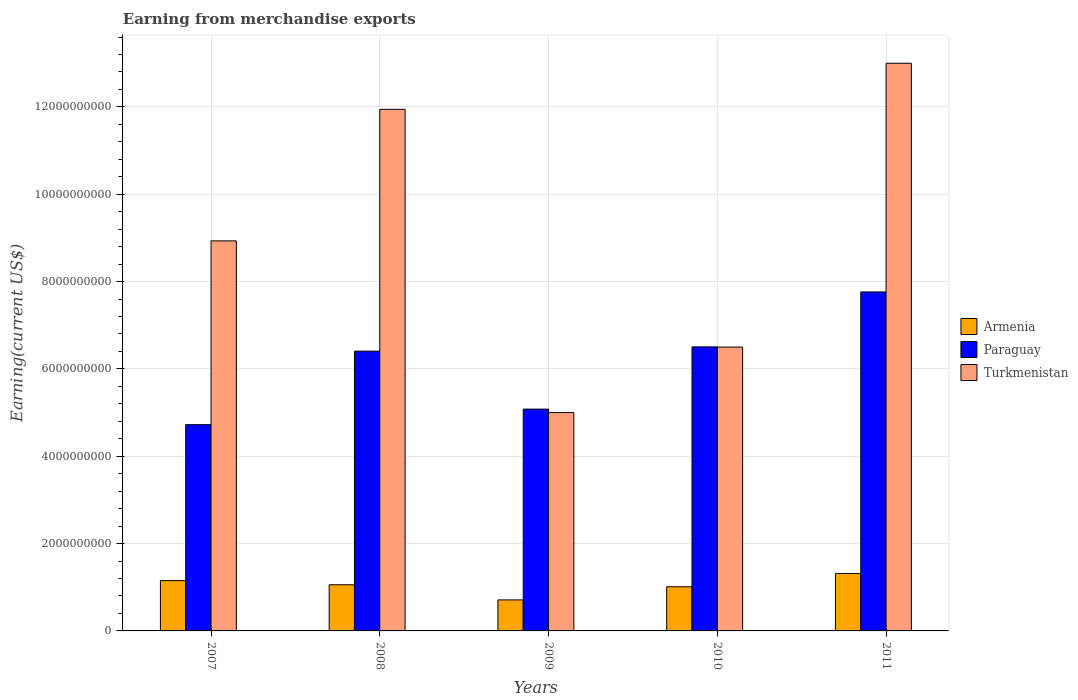How many groups of bars are there?
Your answer should be very brief. 5. Are the number of bars on each tick of the X-axis equal?
Your answer should be very brief. Yes. How many bars are there on the 2nd tick from the left?
Your answer should be very brief. 3. In how many cases, is the number of bars for a given year not equal to the number of legend labels?
Provide a short and direct response. 0. What is the amount earned from merchandise exports in Armenia in 2011?
Offer a terse response. 1.32e+09. Across all years, what is the maximum amount earned from merchandise exports in Turkmenistan?
Make the answer very short. 1.30e+1. Across all years, what is the minimum amount earned from merchandise exports in Paraguay?
Keep it short and to the point. 4.72e+09. In which year was the amount earned from merchandise exports in Paraguay maximum?
Ensure brevity in your answer.  2011. In which year was the amount earned from merchandise exports in Turkmenistan minimum?
Keep it short and to the point. 2009. What is the total amount earned from merchandise exports in Armenia in the graph?
Provide a short and direct response. 5.25e+09. What is the difference between the amount earned from merchandise exports in Turkmenistan in 2008 and that in 2011?
Make the answer very short. -1.06e+09. What is the difference between the amount earned from merchandise exports in Turkmenistan in 2010 and the amount earned from merchandise exports in Paraguay in 2009?
Ensure brevity in your answer.  1.42e+09. What is the average amount earned from merchandise exports in Turkmenistan per year?
Ensure brevity in your answer.  9.08e+09. In the year 2011, what is the difference between the amount earned from merchandise exports in Paraguay and amount earned from merchandise exports in Turkmenistan?
Offer a very short reply. -5.24e+09. In how many years, is the amount earned from merchandise exports in Armenia greater than 800000000 US$?
Make the answer very short. 4. What is the ratio of the amount earned from merchandise exports in Turkmenistan in 2007 to that in 2010?
Ensure brevity in your answer.  1.37. Is the amount earned from merchandise exports in Paraguay in 2007 less than that in 2009?
Your answer should be compact. Yes. What is the difference between the highest and the second highest amount earned from merchandise exports in Armenia?
Ensure brevity in your answer.  1.63e+08. What is the difference between the highest and the lowest amount earned from merchandise exports in Turkmenistan?
Offer a terse response. 8.00e+09. Is the sum of the amount earned from merchandise exports in Turkmenistan in 2008 and 2010 greater than the maximum amount earned from merchandise exports in Paraguay across all years?
Make the answer very short. Yes. What does the 3rd bar from the left in 2008 represents?
Provide a short and direct response. Turkmenistan. What does the 3rd bar from the right in 2010 represents?
Make the answer very short. Armenia. Are all the bars in the graph horizontal?
Offer a terse response. No. How many years are there in the graph?
Offer a terse response. 5. Does the graph contain any zero values?
Provide a succinct answer. No. Does the graph contain grids?
Keep it short and to the point. Yes. Where does the legend appear in the graph?
Your response must be concise. Center right. How many legend labels are there?
Your response must be concise. 3. How are the legend labels stacked?
Make the answer very short. Vertical. What is the title of the graph?
Provide a short and direct response. Earning from merchandise exports. What is the label or title of the Y-axis?
Your response must be concise. Earning(current US$). What is the Earning(current US$) of Armenia in 2007?
Ensure brevity in your answer.  1.15e+09. What is the Earning(current US$) of Paraguay in 2007?
Your response must be concise. 4.72e+09. What is the Earning(current US$) of Turkmenistan in 2007?
Give a very brief answer. 8.93e+09. What is the Earning(current US$) in Armenia in 2008?
Provide a short and direct response. 1.06e+09. What is the Earning(current US$) in Paraguay in 2008?
Your answer should be compact. 6.41e+09. What is the Earning(current US$) of Turkmenistan in 2008?
Your answer should be compact. 1.19e+1. What is the Earning(current US$) of Armenia in 2009?
Offer a very short reply. 7.10e+08. What is the Earning(current US$) in Paraguay in 2009?
Ensure brevity in your answer.  5.08e+09. What is the Earning(current US$) in Turkmenistan in 2009?
Your answer should be compact. 5.00e+09. What is the Earning(current US$) in Armenia in 2010?
Make the answer very short. 1.01e+09. What is the Earning(current US$) in Paraguay in 2010?
Keep it short and to the point. 6.50e+09. What is the Earning(current US$) in Turkmenistan in 2010?
Offer a very short reply. 6.50e+09. What is the Earning(current US$) of Armenia in 2011?
Give a very brief answer. 1.32e+09. What is the Earning(current US$) in Paraguay in 2011?
Provide a short and direct response. 7.76e+09. What is the Earning(current US$) in Turkmenistan in 2011?
Your answer should be very brief. 1.30e+1. Across all years, what is the maximum Earning(current US$) in Armenia?
Keep it short and to the point. 1.32e+09. Across all years, what is the maximum Earning(current US$) of Paraguay?
Keep it short and to the point. 7.76e+09. Across all years, what is the maximum Earning(current US$) of Turkmenistan?
Ensure brevity in your answer.  1.30e+1. Across all years, what is the minimum Earning(current US$) of Armenia?
Your answer should be very brief. 7.10e+08. Across all years, what is the minimum Earning(current US$) of Paraguay?
Give a very brief answer. 4.72e+09. Across all years, what is the minimum Earning(current US$) in Turkmenistan?
Your response must be concise. 5.00e+09. What is the total Earning(current US$) of Armenia in the graph?
Your response must be concise. 5.25e+09. What is the total Earning(current US$) in Paraguay in the graph?
Provide a short and direct response. 3.05e+1. What is the total Earning(current US$) in Turkmenistan in the graph?
Provide a short and direct response. 4.54e+1. What is the difference between the Earning(current US$) in Armenia in 2007 and that in 2008?
Your response must be concise. 9.51e+07. What is the difference between the Earning(current US$) of Paraguay in 2007 and that in 2008?
Give a very brief answer. -1.68e+09. What is the difference between the Earning(current US$) of Turkmenistan in 2007 and that in 2008?
Your response must be concise. -3.01e+09. What is the difference between the Earning(current US$) in Armenia in 2007 and that in 2009?
Offer a very short reply. 4.42e+08. What is the difference between the Earning(current US$) of Paraguay in 2007 and that in 2009?
Make the answer very short. -3.56e+08. What is the difference between the Earning(current US$) in Turkmenistan in 2007 and that in 2009?
Provide a short and direct response. 3.93e+09. What is the difference between the Earning(current US$) in Armenia in 2007 and that in 2010?
Keep it short and to the point. 1.41e+08. What is the difference between the Earning(current US$) in Paraguay in 2007 and that in 2010?
Provide a succinct answer. -1.78e+09. What is the difference between the Earning(current US$) in Turkmenistan in 2007 and that in 2010?
Offer a terse response. 2.43e+09. What is the difference between the Earning(current US$) of Armenia in 2007 and that in 2011?
Keep it short and to the point. -1.63e+08. What is the difference between the Earning(current US$) in Paraguay in 2007 and that in 2011?
Offer a terse response. -3.04e+09. What is the difference between the Earning(current US$) of Turkmenistan in 2007 and that in 2011?
Provide a short and direct response. -4.07e+09. What is the difference between the Earning(current US$) in Armenia in 2008 and that in 2009?
Offer a very short reply. 3.47e+08. What is the difference between the Earning(current US$) of Paraguay in 2008 and that in 2009?
Offer a very short reply. 1.33e+09. What is the difference between the Earning(current US$) of Turkmenistan in 2008 and that in 2009?
Make the answer very short. 6.94e+09. What is the difference between the Earning(current US$) of Armenia in 2008 and that in 2010?
Offer a very short reply. 4.58e+07. What is the difference between the Earning(current US$) in Paraguay in 2008 and that in 2010?
Provide a succinct answer. -9.77e+07. What is the difference between the Earning(current US$) of Turkmenistan in 2008 and that in 2010?
Keep it short and to the point. 5.44e+09. What is the difference between the Earning(current US$) of Armenia in 2008 and that in 2011?
Make the answer very short. -2.58e+08. What is the difference between the Earning(current US$) in Paraguay in 2008 and that in 2011?
Ensure brevity in your answer.  -1.36e+09. What is the difference between the Earning(current US$) in Turkmenistan in 2008 and that in 2011?
Your response must be concise. -1.06e+09. What is the difference between the Earning(current US$) of Armenia in 2009 and that in 2010?
Make the answer very short. -3.01e+08. What is the difference between the Earning(current US$) in Paraguay in 2009 and that in 2010?
Offer a very short reply. -1.43e+09. What is the difference between the Earning(current US$) in Turkmenistan in 2009 and that in 2010?
Make the answer very short. -1.50e+09. What is the difference between the Earning(current US$) of Armenia in 2009 and that in 2011?
Make the answer very short. -6.05e+08. What is the difference between the Earning(current US$) of Paraguay in 2009 and that in 2011?
Offer a terse response. -2.68e+09. What is the difference between the Earning(current US$) in Turkmenistan in 2009 and that in 2011?
Your response must be concise. -8.00e+09. What is the difference between the Earning(current US$) of Armenia in 2010 and that in 2011?
Your answer should be very brief. -3.04e+08. What is the difference between the Earning(current US$) in Paraguay in 2010 and that in 2011?
Your answer should be compact. -1.26e+09. What is the difference between the Earning(current US$) of Turkmenistan in 2010 and that in 2011?
Make the answer very short. -6.50e+09. What is the difference between the Earning(current US$) in Armenia in 2007 and the Earning(current US$) in Paraguay in 2008?
Ensure brevity in your answer.  -5.25e+09. What is the difference between the Earning(current US$) in Armenia in 2007 and the Earning(current US$) in Turkmenistan in 2008?
Your answer should be very brief. -1.08e+1. What is the difference between the Earning(current US$) in Paraguay in 2007 and the Earning(current US$) in Turkmenistan in 2008?
Give a very brief answer. -7.22e+09. What is the difference between the Earning(current US$) of Armenia in 2007 and the Earning(current US$) of Paraguay in 2009?
Offer a very short reply. -3.93e+09. What is the difference between the Earning(current US$) of Armenia in 2007 and the Earning(current US$) of Turkmenistan in 2009?
Offer a terse response. -3.85e+09. What is the difference between the Earning(current US$) of Paraguay in 2007 and the Earning(current US$) of Turkmenistan in 2009?
Keep it short and to the point. -2.76e+08. What is the difference between the Earning(current US$) in Armenia in 2007 and the Earning(current US$) in Paraguay in 2010?
Your answer should be compact. -5.35e+09. What is the difference between the Earning(current US$) of Armenia in 2007 and the Earning(current US$) of Turkmenistan in 2010?
Offer a terse response. -5.35e+09. What is the difference between the Earning(current US$) of Paraguay in 2007 and the Earning(current US$) of Turkmenistan in 2010?
Your answer should be very brief. -1.78e+09. What is the difference between the Earning(current US$) of Armenia in 2007 and the Earning(current US$) of Paraguay in 2011?
Your answer should be very brief. -6.61e+09. What is the difference between the Earning(current US$) of Armenia in 2007 and the Earning(current US$) of Turkmenistan in 2011?
Provide a short and direct response. -1.18e+1. What is the difference between the Earning(current US$) in Paraguay in 2007 and the Earning(current US$) in Turkmenistan in 2011?
Provide a short and direct response. -8.28e+09. What is the difference between the Earning(current US$) of Armenia in 2008 and the Earning(current US$) of Paraguay in 2009?
Provide a short and direct response. -4.02e+09. What is the difference between the Earning(current US$) of Armenia in 2008 and the Earning(current US$) of Turkmenistan in 2009?
Ensure brevity in your answer.  -3.94e+09. What is the difference between the Earning(current US$) of Paraguay in 2008 and the Earning(current US$) of Turkmenistan in 2009?
Offer a very short reply. 1.41e+09. What is the difference between the Earning(current US$) in Armenia in 2008 and the Earning(current US$) in Paraguay in 2010?
Make the answer very short. -5.45e+09. What is the difference between the Earning(current US$) in Armenia in 2008 and the Earning(current US$) in Turkmenistan in 2010?
Make the answer very short. -5.44e+09. What is the difference between the Earning(current US$) in Paraguay in 2008 and the Earning(current US$) in Turkmenistan in 2010?
Provide a short and direct response. -9.29e+07. What is the difference between the Earning(current US$) of Armenia in 2008 and the Earning(current US$) of Paraguay in 2011?
Offer a very short reply. -6.71e+09. What is the difference between the Earning(current US$) in Armenia in 2008 and the Earning(current US$) in Turkmenistan in 2011?
Your response must be concise. -1.19e+1. What is the difference between the Earning(current US$) of Paraguay in 2008 and the Earning(current US$) of Turkmenistan in 2011?
Offer a terse response. -6.59e+09. What is the difference between the Earning(current US$) in Armenia in 2009 and the Earning(current US$) in Paraguay in 2010?
Make the answer very short. -5.79e+09. What is the difference between the Earning(current US$) of Armenia in 2009 and the Earning(current US$) of Turkmenistan in 2010?
Give a very brief answer. -5.79e+09. What is the difference between the Earning(current US$) of Paraguay in 2009 and the Earning(current US$) of Turkmenistan in 2010?
Make the answer very short. -1.42e+09. What is the difference between the Earning(current US$) of Armenia in 2009 and the Earning(current US$) of Paraguay in 2011?
Your response must be concise. -7.05e+09. What is the difference between the Earning(current US$) of Armenia in 2009 and the Earning(current US$) of Turkmenistan in 2011?
Offer a very short reply. -1.23e+1. What is the difference between the Earning(current US$) in Paraguay in 2009 and the Earning(current US$) in Turkmenistan in 2011?
Your response must be concise. -7.92e+09. What is the difference between the Earning(current US$) in Armenia in 2010 and the Earning(current US$) in Paraguay in 2011?
Provide a succinct answer. -6.75e+09. What is the difference between the Earning(current US$) of Armenia in 2010 and the Earning(current US$) of Turkmenistan in 2011?
Your answer should be very brief. -1.20e+1. What is the difference between the Earning(current US$) in Paraguay in 2010 and the Earning(current US$) in Turkmenistan in 2011?
Make the answer very short. -6.50e+09. What is the average Earning(current US$) in Armenia per year?
Your answer should be compact. 1.05e+09. What is the average Earning(current US$) in Paraguay per year?
Your answer should be very brief. 6.10e+09. What is the average Earning(current US$) in Turkmenistan per year?
Offer a very short reply. 9.08e+09. In the year 2007, what is the difference between the Earning(current US$) of Armenia and Earning(current US$) of Paraguay?
Give a very brief answer. -3.57e+09. In the year 2007, what is the difference between the Earning(current US$) of Armenia and Earning(current US$) of Turkmenistan?
Keep it short and to the point. -7.78e+09. In the year 2007, what is the difference between the Earning(current US$) of Paraguay and Earning(current US$) of Turkmenistan?
Your response must be concise. -4.21e+09. In the year 2008, what is the difference between the Earning(current US$) in Armenia and Earning(current US$) in Paraguay?
Offer a terse response. -5.35e+09. In the year 2008, what is the difference between the Earning(current US$) of Armenia and Earning(current US$) of Turkmenistan?
Provide a short and direct response. -1.09e+1. In the year 2008, what is the difference between the Earning(current US$) in Paraguay and Earning(current US$) in Turkmenistan?
Your response must be concise. -5.54e+09. In the year 2009, what is the difference between the Earning(current US$) of Armenia and Earning(current US$) of Paraguay?
Provide a short and direct response. -4.37e+09. In the year 2009, what is the difference between the Earning(current US$) in Armenia and Earning(current US$) in Turkmenistan?
Your response must be concise. -4.29e+09. In the year 2009, what is the difference between the Earning(current US$) of Paraguay and Earning(current US$) of Turkmenistan?
Make the answer very short. 7.96e+07. In the year 2010, what is the difference between the Earning(current US$) in Armenia and Earning(current US$) in Paraguay?
Your answer should be very brief. -5.49e+09. In the year 2010, what is the difference between the Earning(current US$) of Armenia and Earning(current US$) of Turkmenistan?
Offer a very short reply. -5.49e+09. In the year 2010, what is the difference between the Earning(current US$) of Paraguay and Earning(current US$) of Turkmenistan?
Offer a very short reply. 4.82e+06. In the year 2011, what is the difference between the Earning(current US$) of Armenia and Earning(current US$) of Paraguay?
Your response must be concise. -6.45e+09. In the year 2011, what is the difference between the Earning(current US$) in Armenia and Earning(current US$) in Turkmenistan?
Ensure brevity in your answer.  -1.17e+1. In the year 2011, what is the difference between the Earning(current US$) in Paraguay and Earning(current US$) in Turkmenistan?
Your answer should be compact. -5.24e+09. What is the ratio of the Earning(current US$) of Armenia in 2007 to that in 2008?
Keep it short and to the point. 1.09. What is the ratio of the Earning(current US$) in Paraguay in 2007 to that in 2008?
Your answer should be compact. 0.74. What is the ratio of the Earning(current US$) in Turkmenistan in 2007 to that in 2008?
Provide a succinct answer. 0.75. What is the ratio of the Earning(current US$) in Armenia in 2007 to that in 2009?
Provide a succinct answer. 1.62. What is the ratio of the Earning(current US$) of Paraguay in 2007 to that in 2009?
Your response must be concise. 0.93. What is the ratio of the Earning(current US$) in Turkmenistan in 2007 to that in 2009?
Offer a terse response. 1.79. What is the ratio of the Earning(current US$) of Armenia in 2007 to that in 2010?
Offer a very short reply. 1.14. What is the ratio of the Earning(current US$) in Paraguay in 2007 to that in 2010?
Offer a very short reply. 0.73. What is the ratio of the Earning(current US$) in Turkmenistan in 2007 to that in 2010?
Your answer should be very brief. 1.37. What is the ratio of the Earning(current US$) in Armenia in 2007 to that in 2011?
Keep it short and to the point. 0.88. What is the ratio of the Earning(current US$) in Paraguay in 2007 to that in 2011?
Make the answer very short. 0.61. What is the ratio of the Earning(current US$) of Turkmenistan in 2007 to that in 2011?
Offer a terse response. 0.69. What is the ratio of the Earning(current US$) in Armenia in 2008 to that in 2009?
Your response must be concise. 1.49. What is the ratio of the Earning(current US$) in Paraguay in 2008 to that in 2009?
Provide a succinct answer. 1.26. What is the ratio of the Earning(current US$) in Turkmenistan in 2008 to that in 2009?
Provide a short and direct response. 2.39. What is the ratio of the Earning(current US$) of Armenia in 2008 to that in 2010?
Keep it short and to the point. 1.05. What is the ratio of the Earning(current US$) of Paraguay in 2008 to that in 2010?
Provide a succinct answer. 0.98. What is the ratio of the Earning(current US$) of Turkmenistan in 2008 to that in 2010?
Offer a very short reply. 1.84. What is the ratio of the Earning(current US$) in Armenia in 2008 to that in 2011?
Provide a succinct answer. 0.8. What is the ratio of the Earning(current US$) in Paraguay in 2008 to that in 2011?
Ensure brevity in your answer.  0.83. What is the ratio of the Earning(current US$) of Turkmenistan in 2008 to that in 2011?
Provide a short and direct response. 0.92. What is the ratio of the Earning(current US$) in Armenia in 2009 to that in 2010?
Your response must be concise. 0.7. What is the ratio of the Earning(current US$) of Paraguay in 2009 to that in 2010?
Your answer should be compact. 0.78. What is the ratio of the Earning(current US$) in Turkmenistan in 2009 to that in 2010?
Offer a very short reply. 0.77. What is the ratio of the Earning(current US$) in Armenia in 2009 to that in 2011?
Keep it short and to the point. 0.54. What is the ratio of the Earning(current US$) in Paraguay in 2009 to that in 2011?
Your answer should be very brief. 0.65. What is the ratio of the Earning(current US$) in Turkmenistan in 2009 to that in 2011?
Ensure brevity in your answer.  0.38. What is the ratio of the Earning(current US$) of Armenia in 2010 to that in 2011?
Your answer should be very brief. 0.77. What is the ratio of the Earning(current US$) of Paraguay in 2010 to that in 2011?
Your response must be concise. 0.84. What is the ratio of the Earning(current US$) of Turkmenistan in 2010 to that in 2011?
Make the answer very short. 0.5. What is the difference between the highest and the second highest Earning(current US$) in Armenia?
Your response must be concise. 1.63e+08. What is the difference between the highest and the second highest Earning(current US$) of Paraguay?
Make the answer very short. 1.26e+09. What is the difference between the highest and the second highest Earning(current US$) in Turkmenistan?
Provide a succinct answer. 1.06e+09. What is the difference between the highest and the lowest Earning(current US$) in Armenia?
Give a very brief answer. 6.05e+08. What is the difference between the highest and the lowest Earning(current US$) of Paraguay?
Ensure brevity in your answer.  3.04e+09. What is the difference between the highest and the lowest Earning(current US$) in Turkmenistan?
Offer a very short reply. 8.00e+09. 